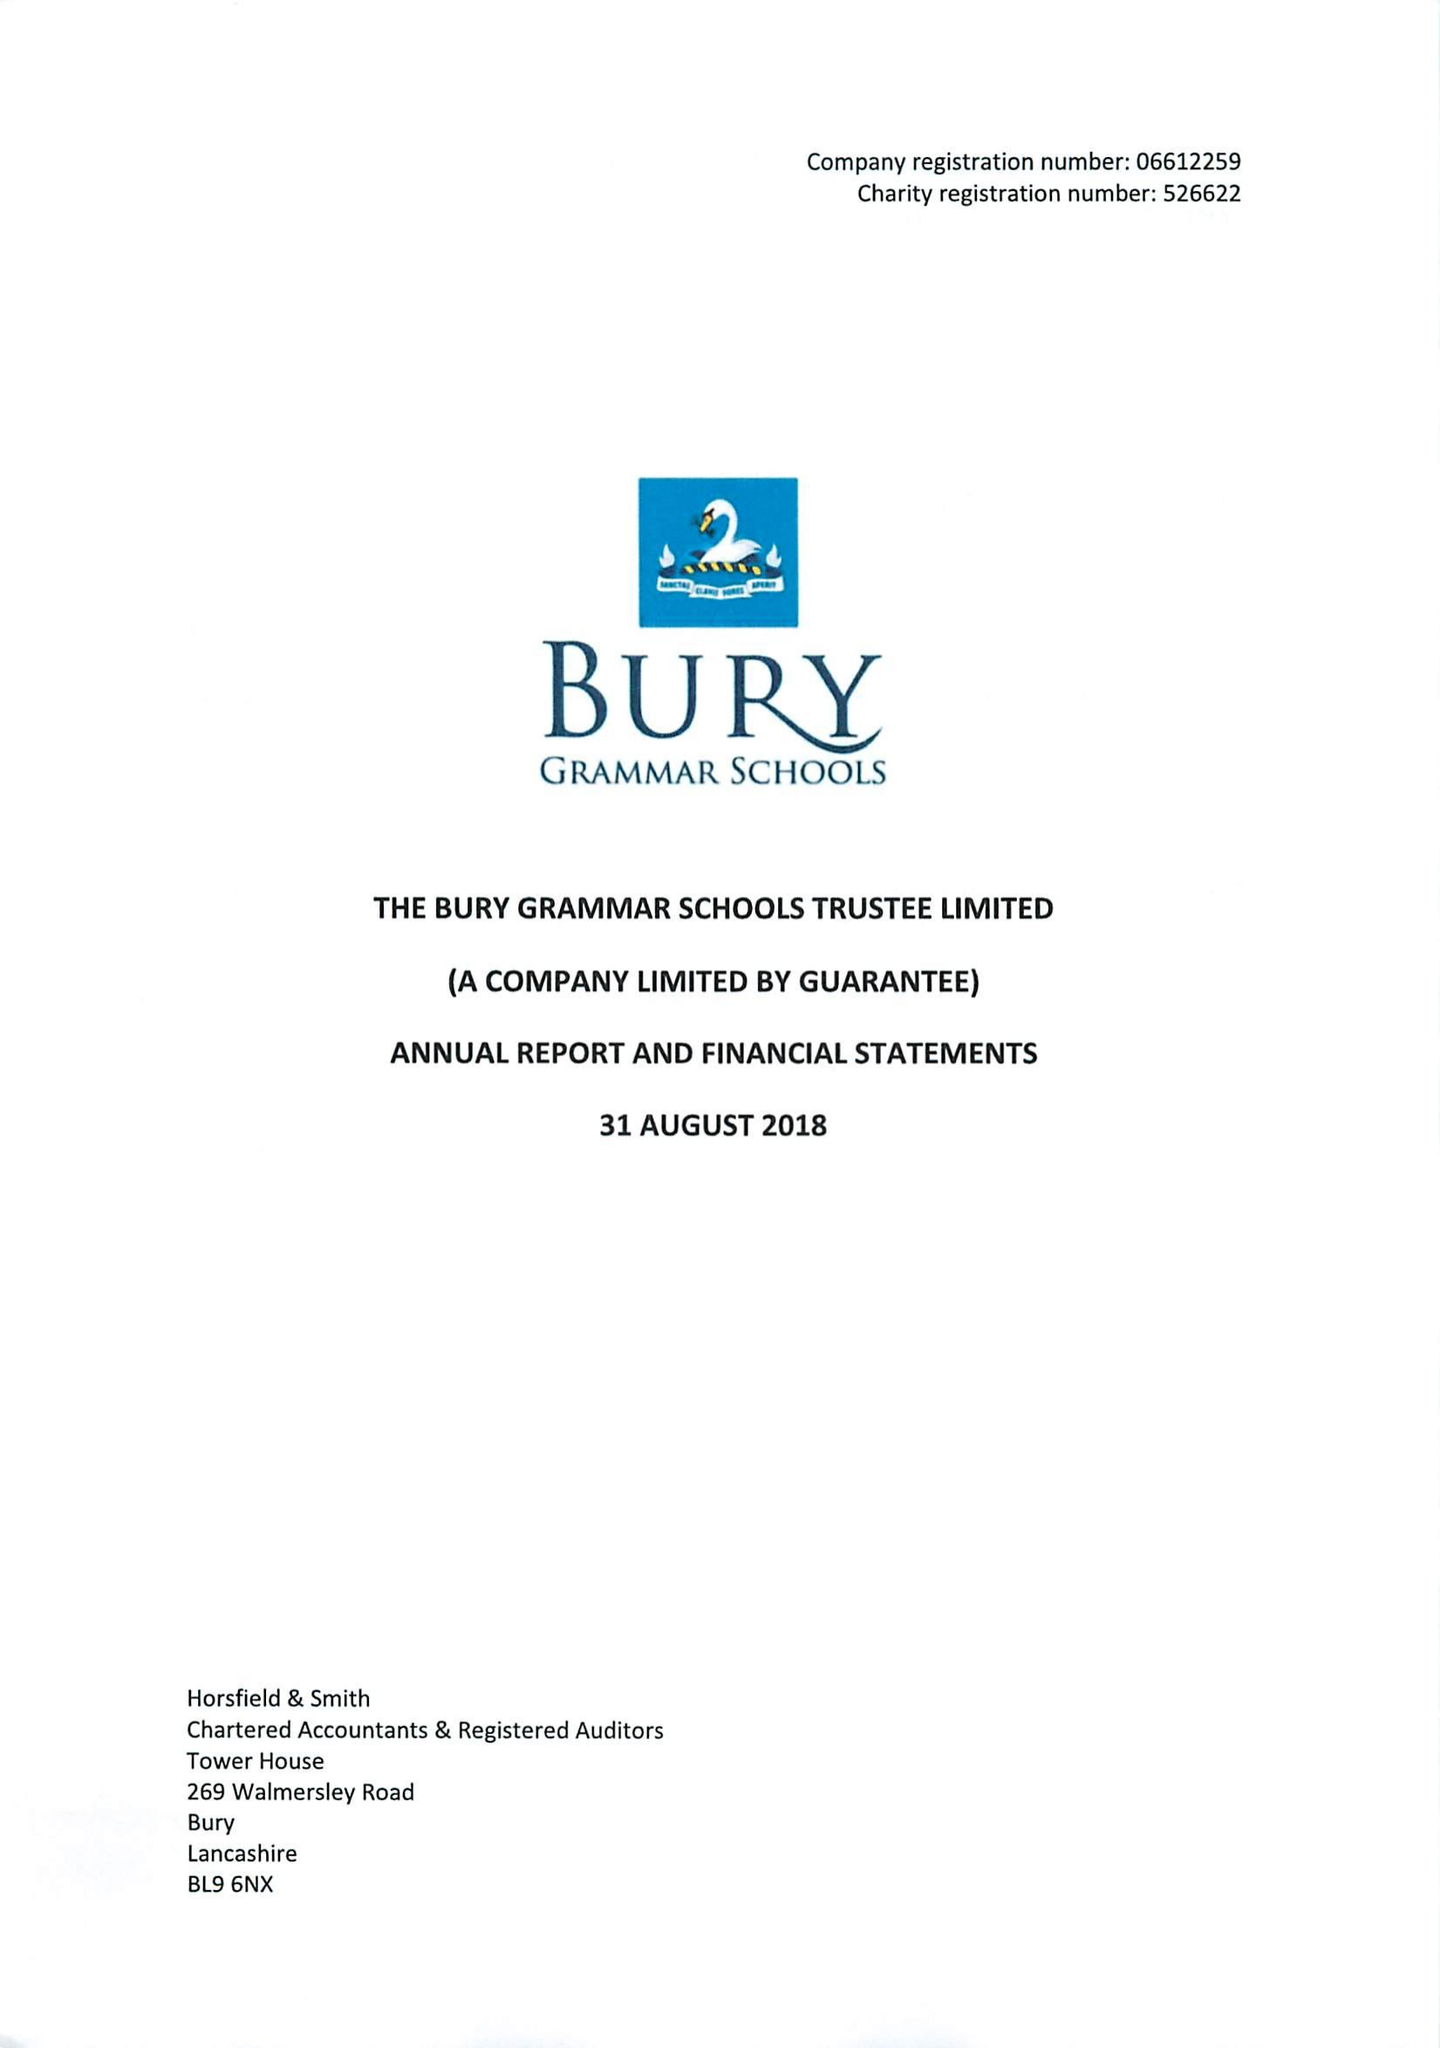What is the value for the spending_annually_in_british_pounds?
Answer the question using a single word or phrase. 11808000.00 